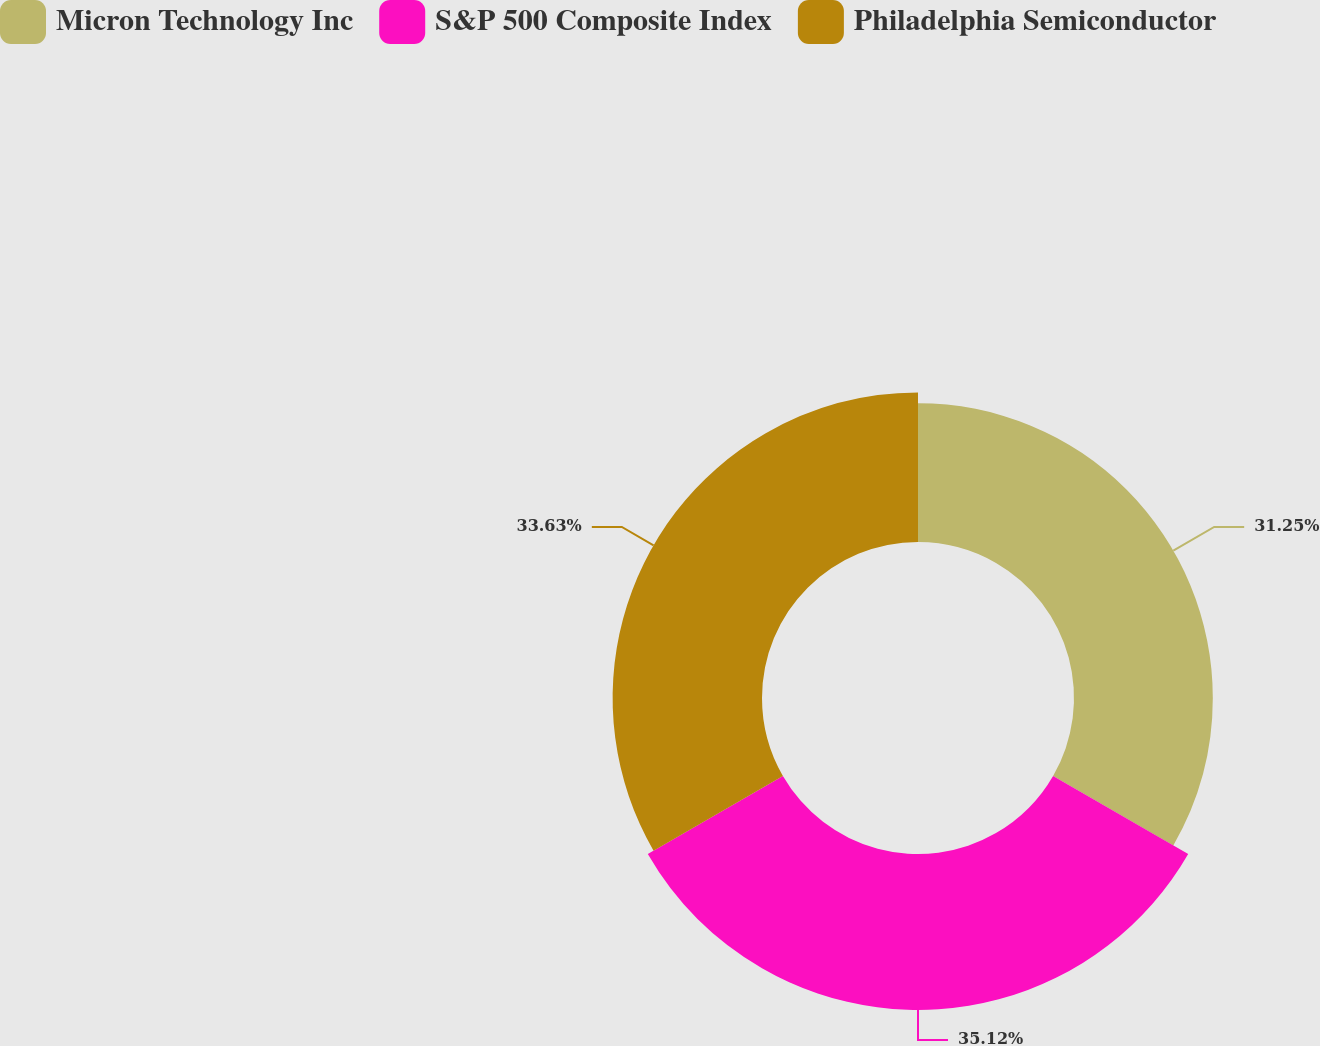Convert chart. <chart><loc_0><loc_0><loc_500><loc_500><pie_chart><fcel>Micron Technology Inc<fcel>S&P 500 Composite Index<fcel>Philadelphia Semiconductor<nl><fcel>31.25%<fcel>35.12%<fcel>33.63%<nl></chart> 